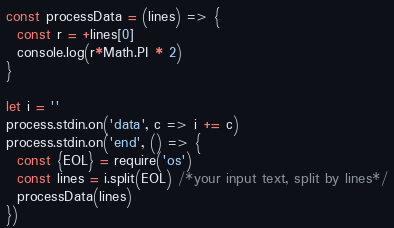Convert code to text. <code><loc_0><loc_0><loc_500><loc_500><_JavaScript_>const processData = (lines) => {
  const r = +lines[0]
  console.log(r*Math.PI * 2)
}

let i = ''
process.stdin.on('data', c => i += c)
process.stdin.on('end', () => {
  const {EOL} = require('os')
  const lines = i.split(EOL) /*your input text, split by lines*/
  processData(lines)
})
</code> 